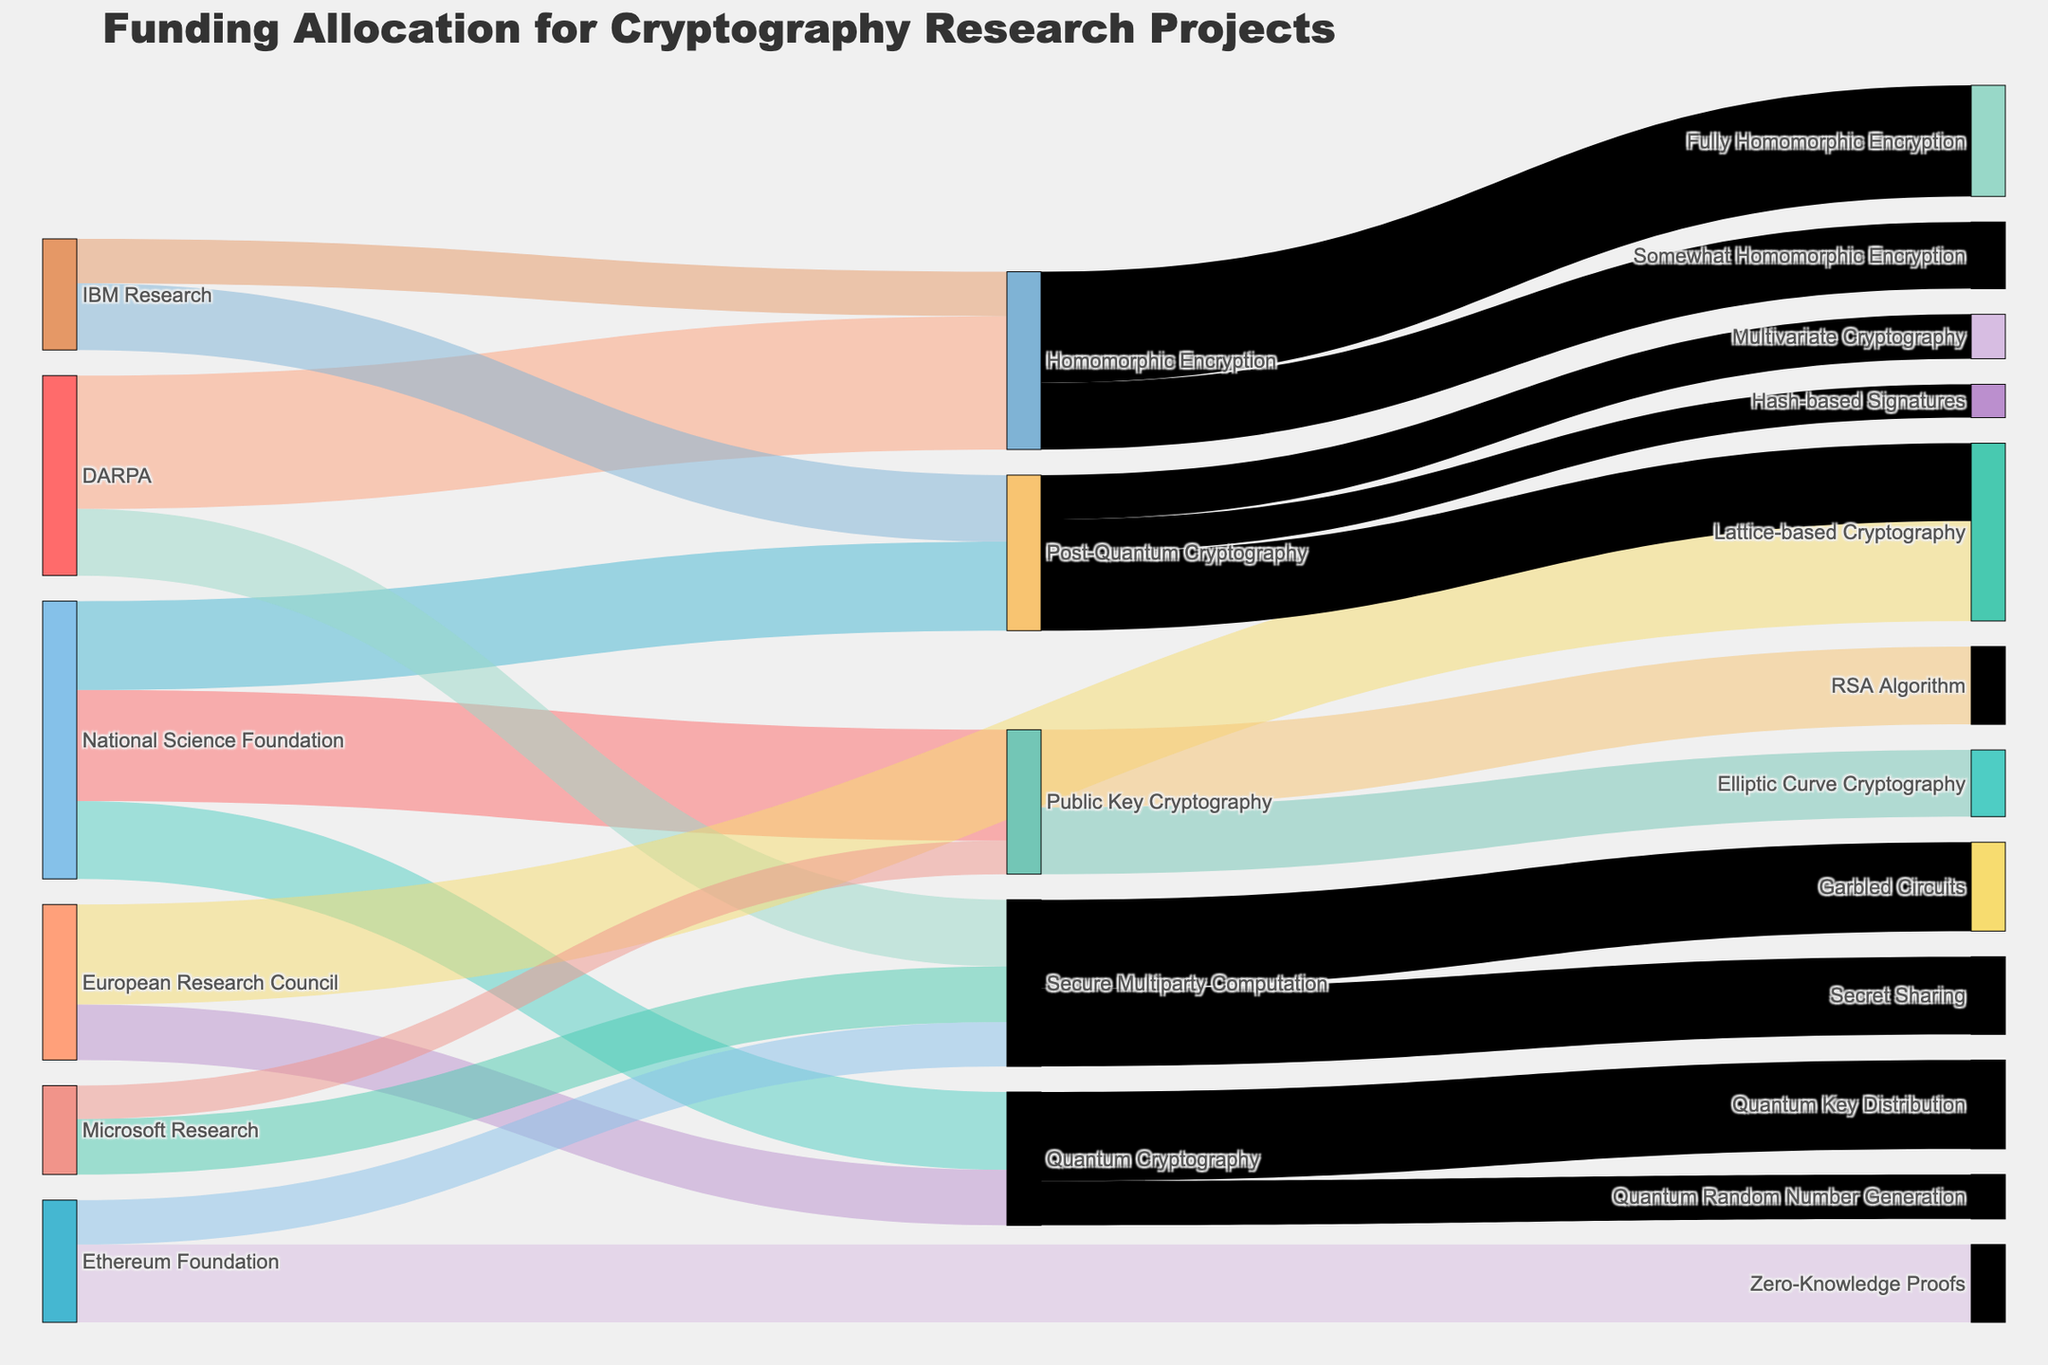What is the total funding from the National Science Foundation to all research areas? Add the funding allocated to each research area by the National Science Foundation: Public Key Cryptography (5,000,000), Quantum Cryptography (3,500,000), Post-Quantum Cryptography (4,000,000). The sum is 5,000,000 + 3,500,000 + 4,000,000 = 12,500,000
Answer: 12,500,000 Which research area received the highest funding? Look for the research area with the highest value among all the flows in the diagram. In this case, Homomorphic Encryption received 6,000,000 from DARPA, the highest amount
Answer: Homomorphic Encryption How much funding in total is allocated to Quantum Cryptography, and which organizations contributed to it? Identify the sources contributing to Quantum Cryptography and sum their values: National Science Foundation (3,500,000) and European Research Council (2,500,000). The total is 3,500,000 + 2,500,000 = 6,000,000
Answer: 6,000,000; National Science Foundation, European Research Council What is the difference in funding between Post-Quantum Cryptography and Secure Multiparty Computation? Sum the values for both research areas: Post-Quantum Cryptography (4,000,000 NSF + 3,000,000 IBM = 7,000,000), Secure Multiparty Computation (3,000,000 DARPA + 2,500,000 Microsoft + 2,000,000 Ethereum = 7,500,000). The difference is 7,500,000 - 7,000,000 = 500,000
Answer: 500,000 Which areas does IBM Research fund and how much in total? Identify the areas funded by IBM Research and sum the values: Post-Quantum Cryptography (3,000,000) and Homomorphic Encryption (2,000,000). The total is 3,000,000 + 2,000,000 = 5,000,000
Answer: Post-Quantum Cryptography, Homomorphic Encryption; 5,000,000 What are the sub-categories of funding for Public Key Cryptography, and how much funding do they receive? Look for the targets linked to Public Key Cryptography: RSA Algorithm (3,500,000) and Elliptic Curve Cryptography (3,000,000). They receive 3,500,000 and 3,000,000 respectively
Answer: RSA Algorithm: 3,500,000; Elliptic Curve Cryptography: 3,000,000 Which organization provides the largest single contribution, and to which area? Look for the highest value of a single funding contribution: DARPA to Homomorphic Encryption with 6,000,000
Answer: DARPA to Homomorphic Encryption Compare the combined funding for Lattice-based Cryptography from all sources to that for Secure Multiparty Computation Lattice-based Cryptography has funding from European Research Council (4,500,000) and Post-Quantum Cryptography (3,500,000); total 4,500,000 + 3,500,000 = 8,000,000. Secure Multiparty Computation has funding from DARPA (3,000,000), Microsoft Research (2,500,000), and Ethereum Foundation (2,000,000); total 3,000,000 + 2,500,000 + 2,000,000 = 7,500,000. Thus, Lattice-based Cryptography has more funding
Answer: Lattice-based Cryptography: 8,000,000; Secure Multiparty Computation: 7,500,000 What is the funding allocated to Fully Homomorphic Encryption from Homomorphic Encryption? Look for the amount flowing from Homomorphic Encryption to Fully Homomorphic Encryption, which is 5,000,000
Answer: 5,000,000 